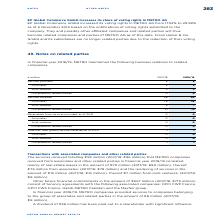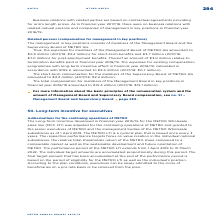According to Metro Ag's financial document, What was the amount of services provided in FY2019? According to the financial document, 8 (in millions). The relevant text states: "In financial year 2018/19, METRO maintained the following business relations to related..." Also, Who were the parties to which METRO maintained business relations with related companies? The document contains multiple relevant values: Associates, Joint ventures, Miscellaneous related parties. From the document: "Joint ventures 3 3 Miscellaneous related parties 0 0 Associates 5 5..." Also, What were the business relations to related companies listed in the table? The document contains multiple relevant values: Services provided, Services received, Receivables from services provided, as of 30/9, Liabilities from goods/services received as of 30/9. From the document: "Receivables from services provided, as of 30/9 0 0 Liabilities from goods/services received as of 30/9 1 1 Liabilities from goods/services received as..." Additionally, In which year were services received larger? According to the financial document, 2018. The relevant text states: "In financial year 2018/19, METRO maintained the following business relations to related..." Also, can you calculate: What was the change in services received in FY2019 from FY2018? Based on the calculation: 93-96, the result is -3 (in millions). This is based on the information: "Services received 96 93 Services received 96 93..." The key data points involved are: 93, 96. Also, can you calculate: What was the percentage change in services received in FY2019 from FY2018? To answer this question, I need to perform calculations using the financial data. The calculation is: (93-96)/96, which equals -3.12 (percentage). This is based on the information: "Services received 96 93 Services received 96 93..." The key data points involved are: 93, 96. 